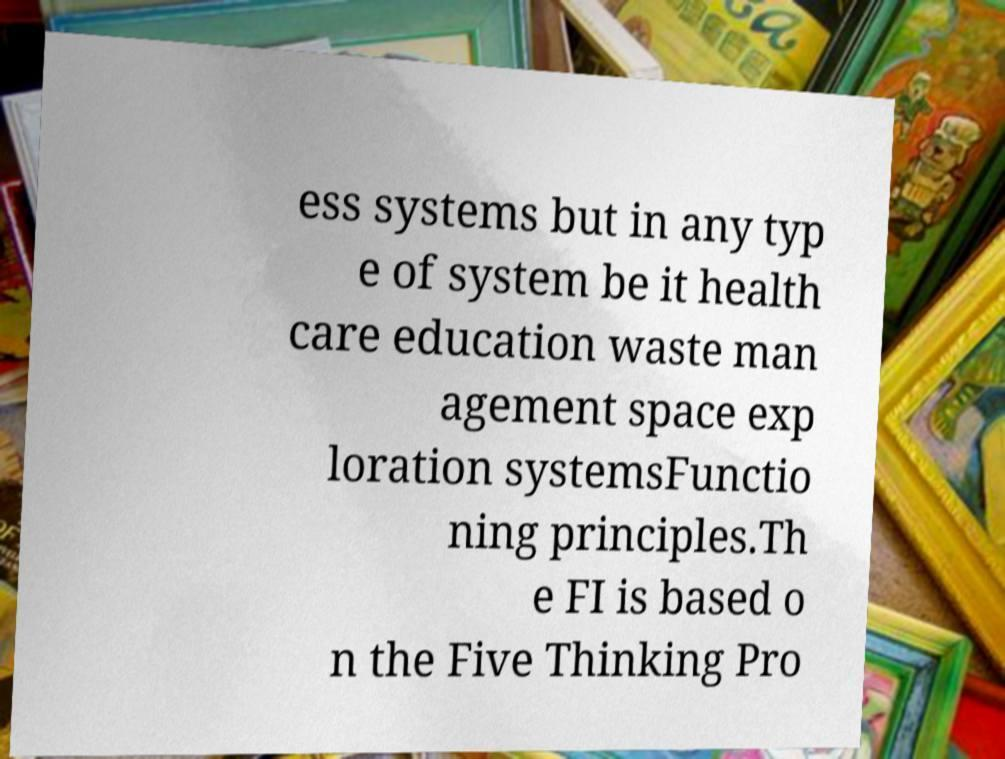For documentation purposes, I need the text within this image transcribed. Could you provide that? ess systems but in any typ e of system be it health care education waste man agement space exp loration systemsFunctio ning principles.Th e FI is based o n the Five Thinking Pro 